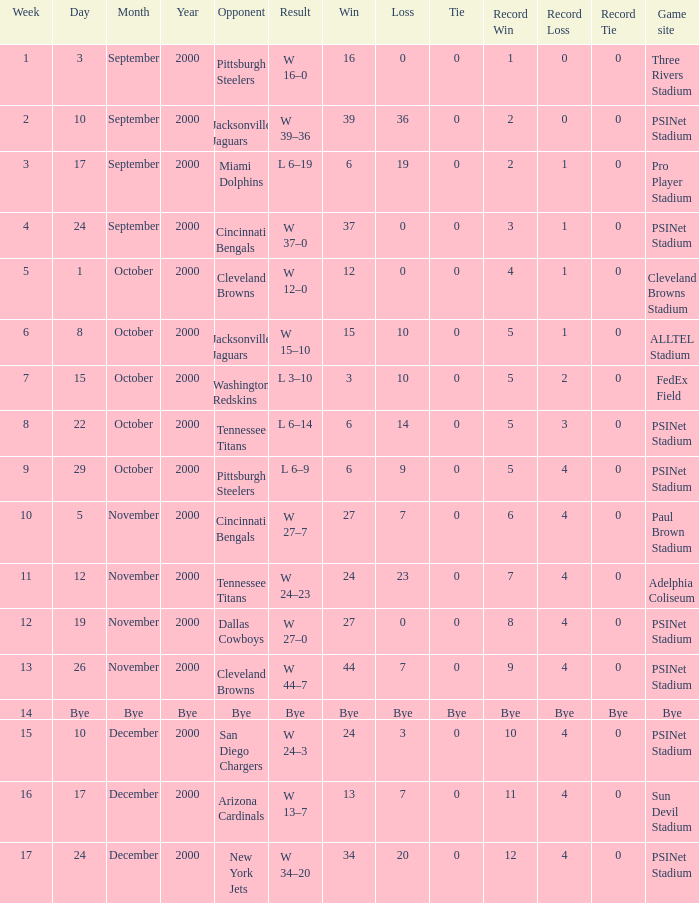What's the result at psinet stadium when the cincinnati bengals are the opponent? W 37–0. 